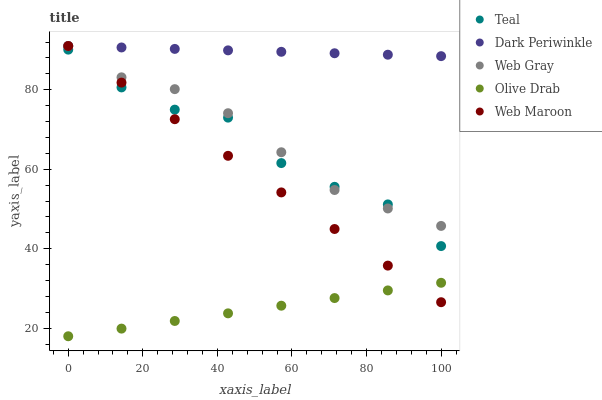Does Olive Drab have the minimum area under the curve?
Answer yes or no. Yes. Does Dark Periwinkle have the maximum area under the curve?
Answer yes or no. Yes. Does Web Gray have the minimum area under the curve?
Answer yes or no. No. Does Web Gray have the maximum area under the curve?
Answer yes or no. No. Is Olive Drab the smoothest?
Answer yes or no. Yes. Is Teal the roughest?
Answer yes or no. Yes. Is Web Gray the smoothest?
Answer yes or no. No. Is Web Gray the roughest?
Answer yes or no. No. Does Olive Drab have the lowest value?
Answer yes or no. Yes. Does Web Gray have the lowest value?
Answer yes or no. No. Does Dark Periwinkle have the highest value?
Answer yes or no. Yes. Does Teal have the highest value?
Answer yes or no. No. Is Teal less than Dark Periwinkle?
Answer yes or no. Yes. Is Dark Periwinkle greater than Teal?
Answer yes or no. Yes. Does Web Maroon intersect Teal?
Answer yes or no. Yes. Is Web Maroon less than Teal?
Answer yes or no. No. Is Web Maroon greater than Teal?
Answer yes or no. No. Does Teal intersect Dark Periwinkle?
Answer yes or no. No. 